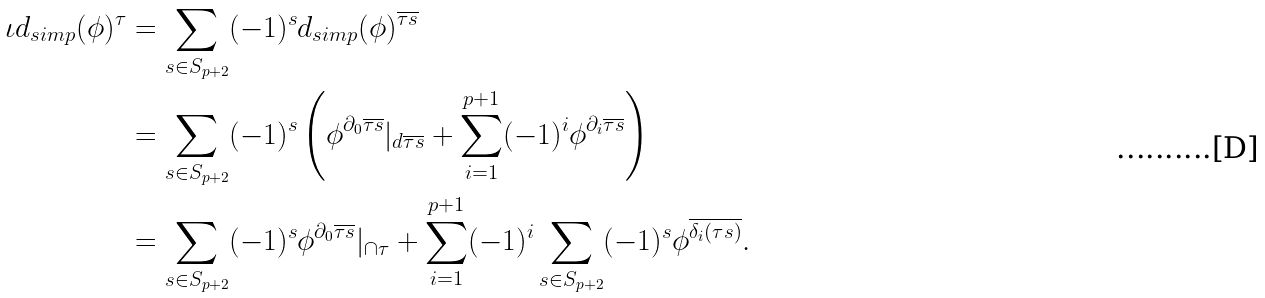<formula> <loc_0><loc_0><loc_500><loc_500>\iota d _ { s i m p } ( \phi ) ^ { \tau } & = \sum _ { s \in S _ { p + 2 } } ( - 1 ) ^ { s } d _ { s i m p } ( \phi ) ^ { \overline { \tau s } } \\ & = \sum _ { s \in S _ { p + 2 } } ( - 1 ) ^ { s } \left ( \phi ^ { \partial _ { 0 } \overline { \tau s } } | _ { d \overline { \tau s } } + \sum _ { i = 1 } ^ { p + 1 } ( - 1 ) ^ { i } \phi ^ { \partial _ { i } \overline { \tau s } } \right ) \\ & = \sum _ { s \in S _ { p + 2 } } ( - 1 ) ^ { s } \phi ^ { \partial _ { 0 } \overline { \tau s } } | _ { \cap \tau } + \sum _ { i = 1 } ^ { p + 1 } ( - 1 ) ^ { i } \sum _ { s \in S _ { p + 2 } } ( - 1 ) ^ { s } \phi ^ { \overline { \delta _ { i } ( \tau s ) } } .</formula> 